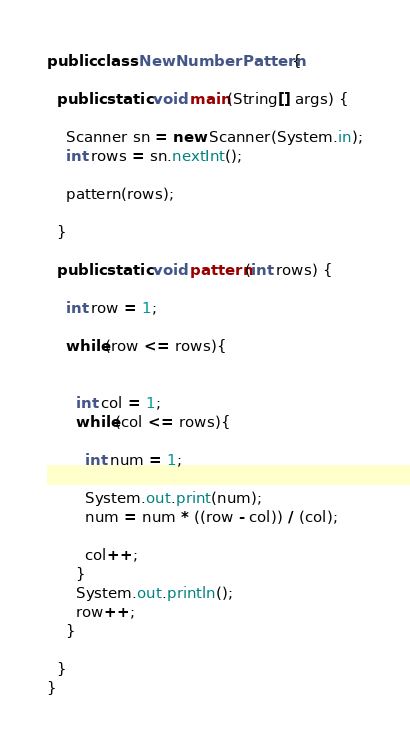<code> <loc_0><loc_0><loc_500><loc_500><_Java_>
public class NewNumberPattern {
  
  public static void main(String[] args) {
    
    Scanner sn = new Scanner(System.in);
    int rows = sn.nextInt();

    pattern(rows);

  }

  public static void pattern(int rows) {

    int row = 1;

    while(row <= rows){

      
      int col = 1;
      while(col <= rows){

        int num = 1;

        System.out.print(num);
        num = num * ((row - col)) / (col);

        col++;
      }
      System.out.println();
      row++;
    }
    
  }
}</code> 